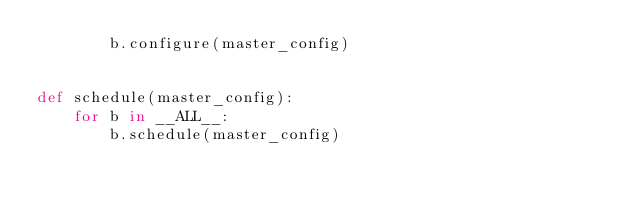<code> <loc_0><loc_0><loc_500><loc_500><_Python_>        b.configure(master_config)


def schedule(master_config):
    for b in __ALL__:
        b.schedule(master_config)
</code> 